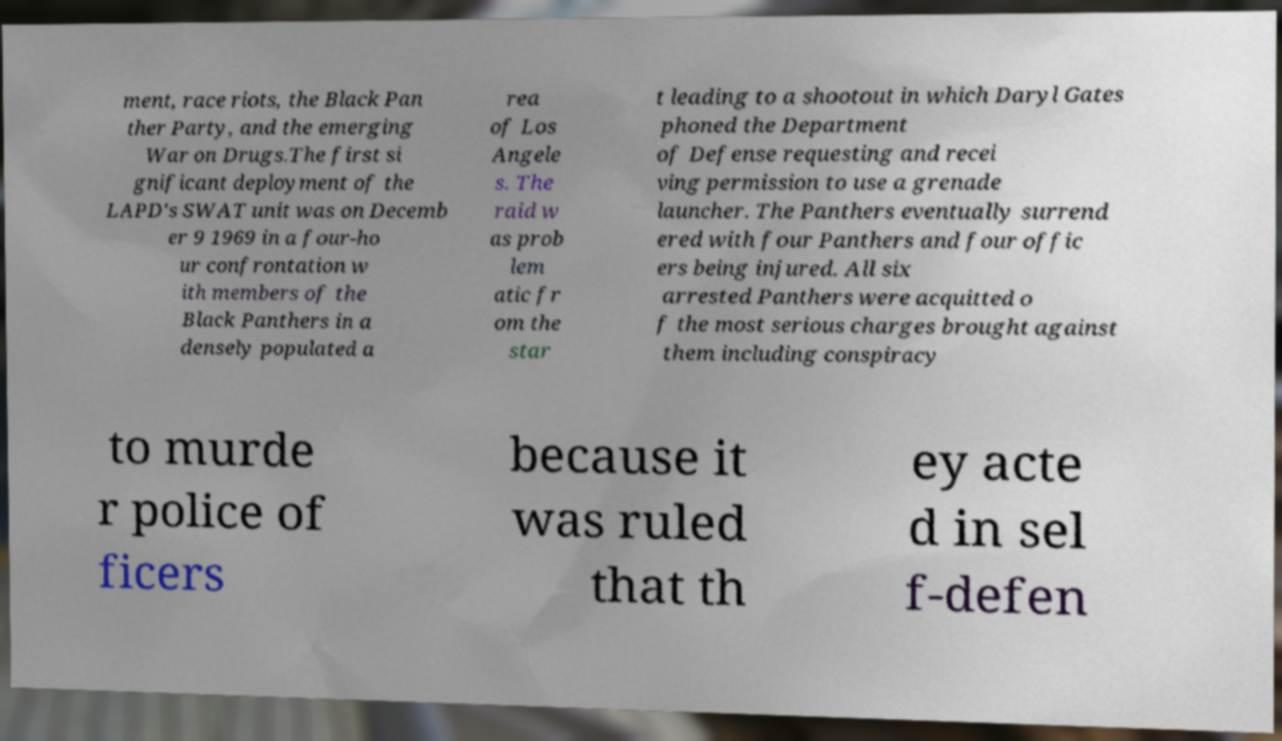Could you assist in decoding the text presented in this image and type it out clearly? ment, race riots, the Black Pan ther Party, and the emerging War on Drugs.The first si gnificant deployment of the LAPD's SWAT unit was on Decemb er 9 1969 in a four-ho ur confrontation w ith members of the Black Panthers in a densely populated a rea of Los Angele s. The raid w as prob lem atic fr om the star t leading to a shootout in which Daryl Gates phoned the Department of Defense requesting and recei ving permission to use a grenade launcher. The Panthers eventually surrend ered with four Panthers and four offic ers being injured. All six arrested Panthers were acquitted o f the most serious charges brought against them including conspiracy to murde r police of ficers because it was ruled that th ey acte d in sel f-defen 